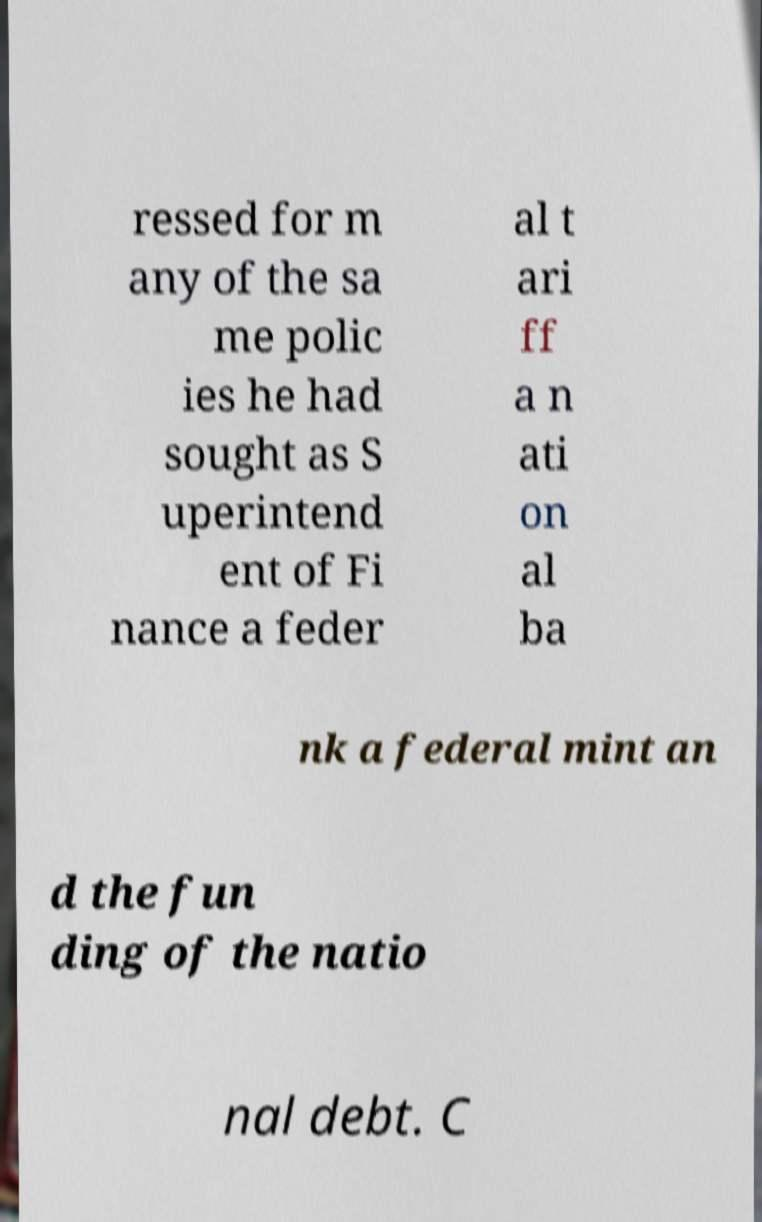Can you accurately transcribe the text from the provided image for me? ressed for m any of the sa me polic ies he had sought as S uperintend ent of Fi nance a feder al t ari ff a n ati on al ba nk a federal mint an d the fun ding of the natio nal debt. C 